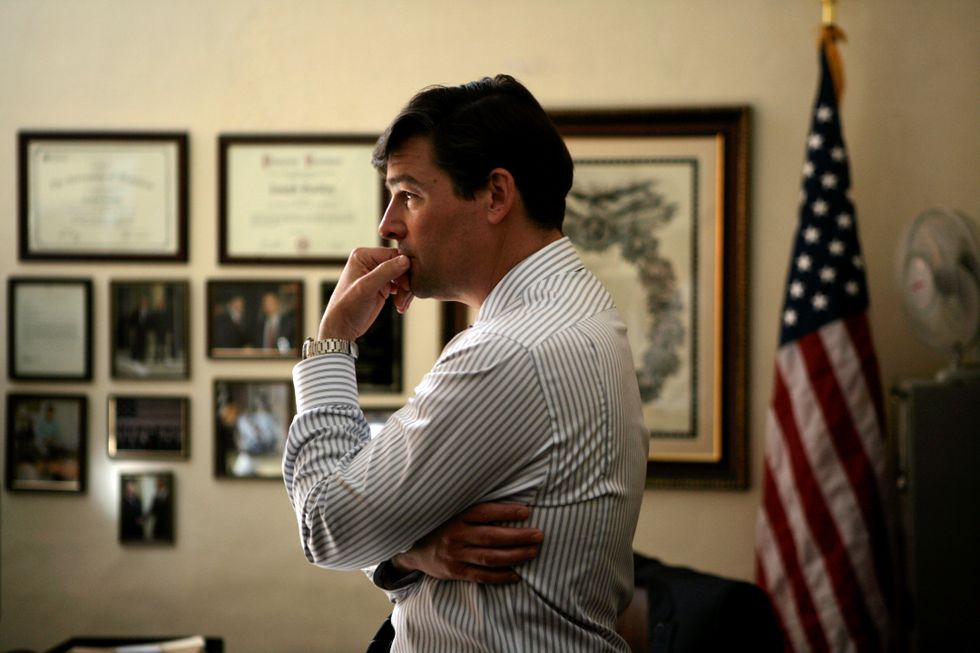What do you notice about the individual's body language and what might it suggest about his current state of mind? The individual's body language, with his hand on his chin and arms crossed, suggests that he might be in deep thought or contemplation. This pose often indicates concentration, analysis, or even concern. The setting, adorned with certificates and an American flag, adds a serious undertone to his demeanor, implying he might be contemplating something significant or perhaps reflecting on a critical decision. How does the room's decor contribute to the overall impression of the scene? The room's decor significantly contributes to the overall impression of the scene, lending it an air of professionalism and significance. The certificates and framed photos on the wall suggest achievement and a career of noted success or recognition. The presence of the American flag adds a patriotic element, perhaps indicating the room belongs to someone in a position of leadership or public service. This combination of elements underscores the idea that the individual in the scene is contemplating something important within a serious, professional context. 